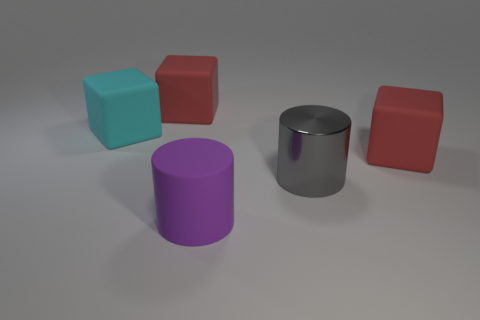Is there any other thing that is the same material as the gray object?
Your answer should be compact. No. There is a large thing that is both left of the large gray shiny thing and in front of the cyan cube; what material is it?
Your response must be concise. Rubber. There is a red object that is to the right of the large gray metal cylinder; is there a red matte thing that is behind it?
Provide a succinct answer. Yes. Are the large cyan object and the gray object made of the same material?
Your answer should be very brief. No. Are there any cubes to the left of the big purple cylinder?
Make the answer very short. Yes. The red object that is right of the gray cylinder in front of the large cyan rubber thing is made of what material?
Offer a very short reply. Rubber. What is the size of the shiny thing that is the same shape as the purple rubber thing?
Your answer should be compact. Large. Is the big metallic cylinder the same color as the rubber cylinder?
Keep it short and to the point. No. What is the color of the thing that is to the right of the purple cylinder and behind the large gray cylinder?
Your answer should be very brief. Red. Is the size of the cyan object that is left of the gray metallic cylinder the same as the big matte cylinder?
Make the answer very short. Yes. 